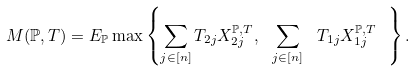Convert formula to latex. <formula><loc_0><loc_0><loc_500><loc_500>M ( \mathbb { P } , T ) = E _ { \mathbb { P } } \max \left \{ \sum _ { j \in [ n ] } T _ { 2 j } X _ { 2 j } ^ { \mathbb { P } , T } , \ \sum _ { j \in [ n ] } \ T _ { 1 j } X _ { 1 j } ^ { \mathbb { P } , T } \ \right \} .</formula> 